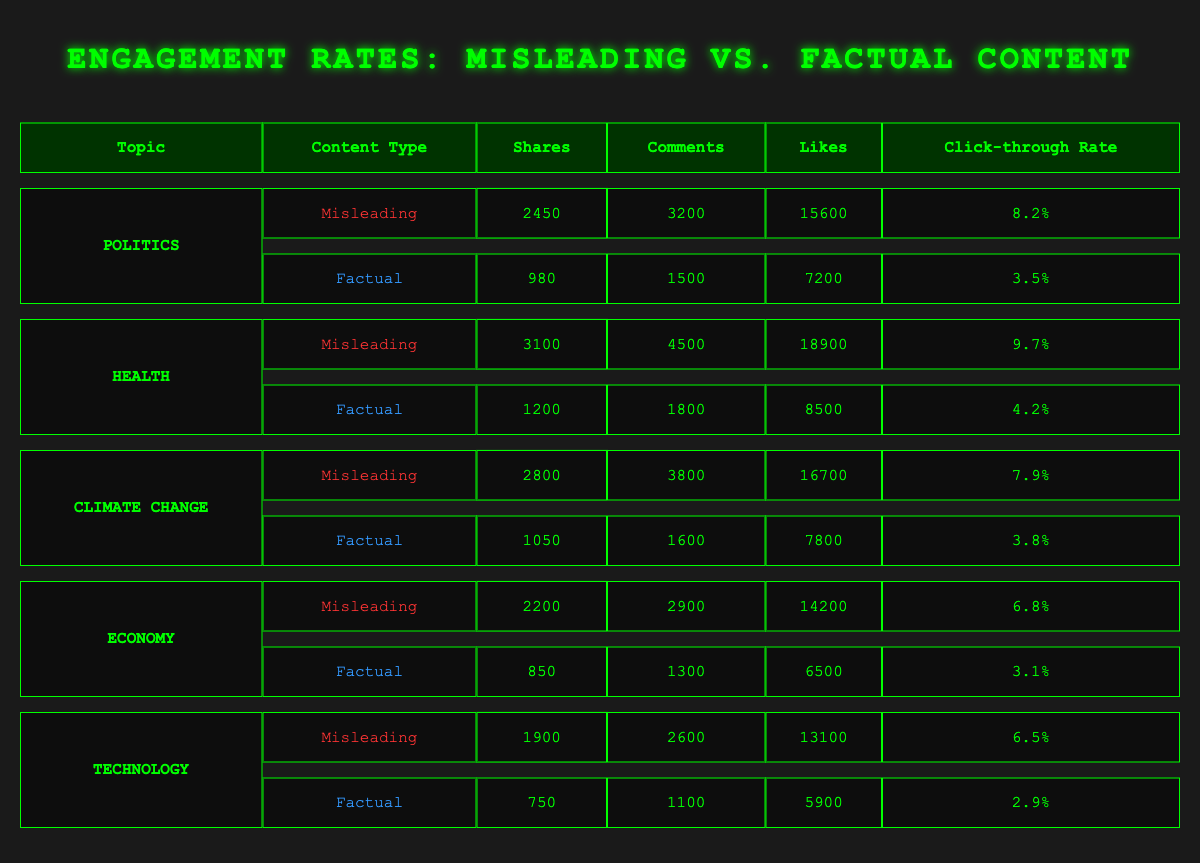What is the highest number of shares for misleading content across all topics? The topic with the highest shares for misleading content is Health, which has 3100 shares.
Answer: 3100 Which topic has the lowest click-through rate for factual content? The lowest click-through rate for factual content is in the Technology topic at 2.9%.
Answer: 2.9% What is the difference in comments between misleading content and factual content in the Politics topic? The misleading content in Politics received 3200 comments, while the factual content received 1500 comments. The difference is 3200 - 1500 = 1700 comments.
Answer: 1700 Is the number of likes for misleading content in the Health topic greater than the likes for factual content in the Economy topic? Misleading content in Health has 18900 likes while factual content in Economy has 6500 likes. Since 18900 is greater than 6500, the statement is true.
Answer: Yes What is the sum of shares for misleading content across all topics? The shares for misleading content are as follows: Politics 2450, Health 3100, Climate Change 2800, Economy 2200, and Technology 1900. Summing these gives 2450 + 3100 + 2800 + 2200 + 1900 = 12450 shares.
Answer: 12450 How many comments do factual content posts receive on average across all topics? The number of comments for factual content are: Politics 1500, Health 1800, Climate Change 1600, Economy 1300, and Technology 1100. The average is (1500 + 1800 + 1600 + 1300 + 1100) / 5 = 1460 comments.
Answer: 1460 For which topic is the ratio of shares for misleading content to factual content the highest? The shares for misleading content and factual content per topic are: Politics (2450/980), Health (3100/1200), Climate Change (2800/1050), Economy (2200/850), Technology (1900/750). Calculating these ratios gives: Politics 2.5, Health 2.58, Climate Change 2.67, Economy 2.59, Technology 2.53. The highest ratio is for Climate Change at 2.67.
Answer: Climate Change Does misleading content outperform factual content in the number of likes for all topics? For each topic, we compare likes: Politics (15600 vs 7200), Health (18900 vs 8500), Climate Change (16700 vs 7800), Economy (14200 vs 6500), Technology (13100 vs 5900). In all cases, misleading content outperforms factual content, hence the statement is true.
Answer: Yes 